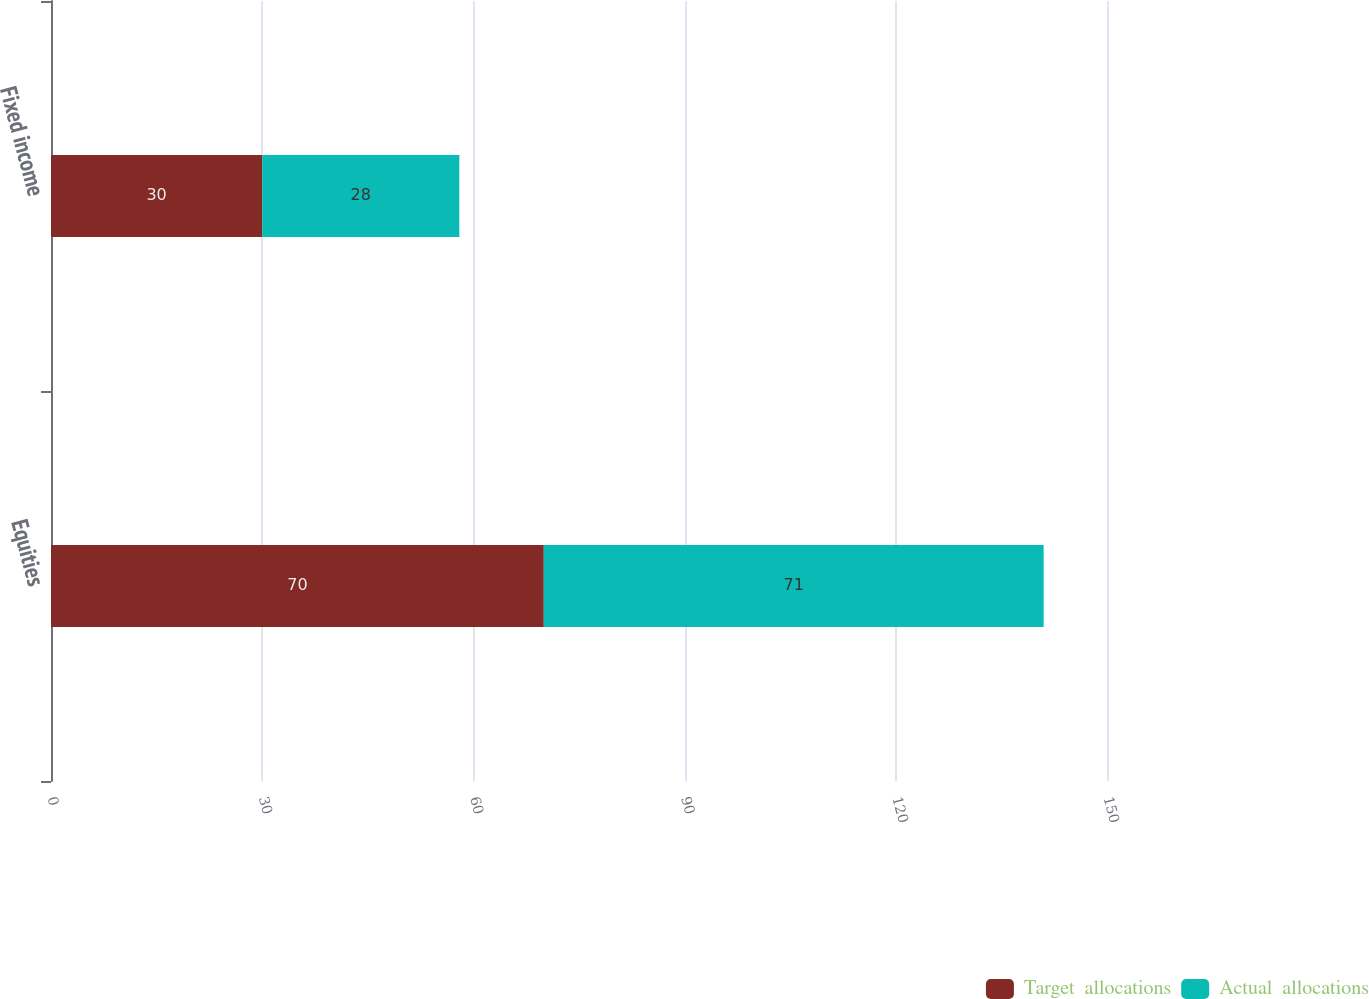Convert chart to OTSL. <chart><loc_0><loc_0><loc_500><loc_500><stacked_bar_chart><ecel><fcel>Equities<fcel>Fixed income<nl><fcel>Target  allocations<fcel>70<fcel>30<nl><fcel>Actual  allocations<fcel>71<fcel>28<nl></chart> 